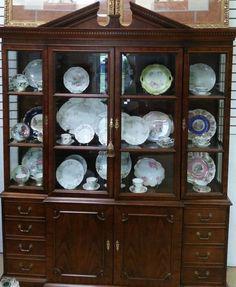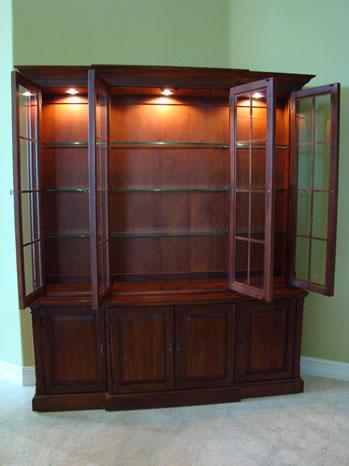The first image is the image on the left, the second image is the image on the right. For the images shown, is this caption "The cabinet in the image on the right is set in the corner of a room." true? Answer yes or no. Yes. The first image is the image on the left, the second image is the image on the right. For the images displayed, is the sentence "A wooden hutch with three rows of dishes in its upper glass-paned section has three drawers between two doors in its lower section." factually correct? Answer yes or no. No. 